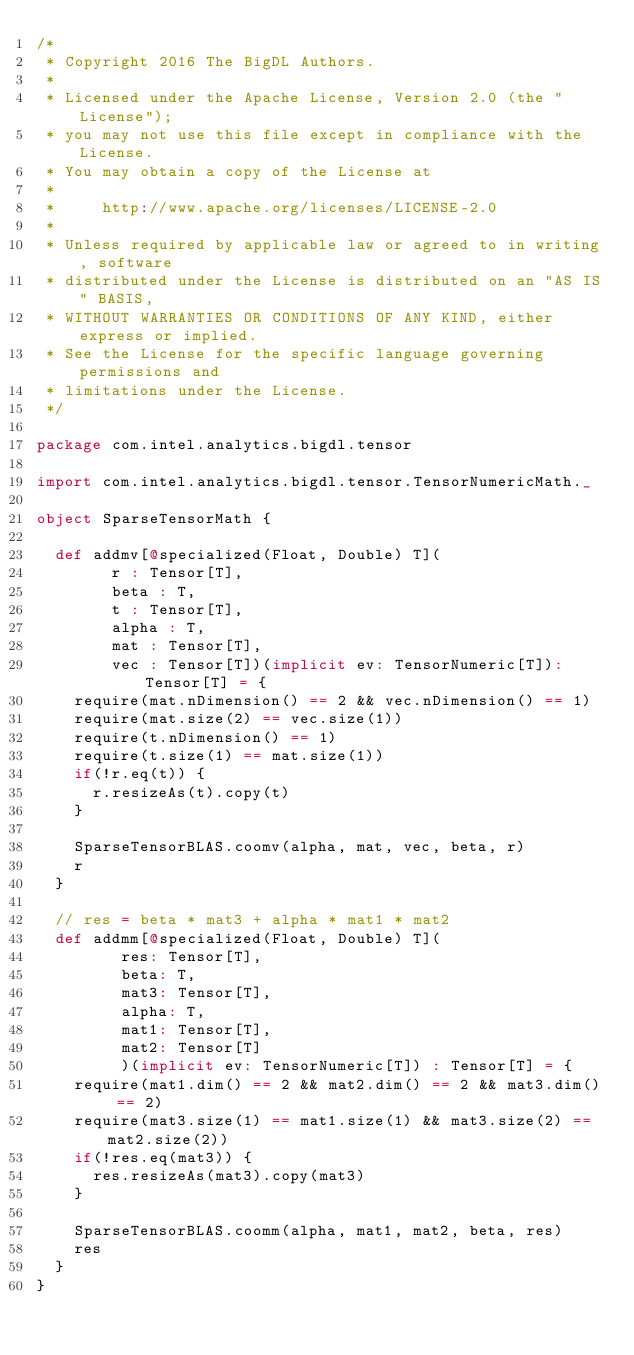<code> <loc_0><loc_0><loc_500><loc_500><_Scala_>/*
 * Copyright 2016 The BigDL Authors.
 *
 * Licensed under the Apache License, Version 2.0 (the "License");
 * you may not use this file except in compliance with the License.
 * You may obtain a copy of the License at
 *
 *     http://www.apache.org/licenses/LICENSE-2.0
 *
 * Unless required by applicable law or agreed to in writing, software
 * distributed under the License is distributed on an "AS IS" BASIS,
 * WITHOUT WARRANTIES OR CONDITIONS OF ANY KIND, either express or implied.
 * See the License for the specific language governing permissions and
 * limitations under the License.
 */

package com.intel.analytics.bigdl.tensor

import com.intel.analytics.bigdl.tensor.TensorNumericMath._

object SparseTensorMath {

  def addmv[@specialized(Float, Double) T](
        r : Tensor[T],
        beta : T,
        t : Tensor[T],
        alpha : T,
        mat : Tensor[T],
        vec : Tensor[T])(implicit ev: TensorNumeric[T]): Tensor[T] = {
    require(mat.nDimension() == 2 && vec.nDimension() == 1)
    require(mat.size(2) == vec.size(1))
    require(t.nDimension() == 1)
    require(t.size(1) == mat.size(1))
    if(!r.eq(t)) {
      r.resizeAs(t).copy(t)
    }

    SparseTensorBLAS.coomv(alpha, mat, vec, beta, r)
    r
  }

  // res = beta * mat3 + alpha * mat1 * mat2
  def addmm[@specialized(Float, Double) T](
         res: Tensor[T],
         beta: T,
         mat3: Tensor[T],
         alpha: T,
         mat1: Tensor[T],
         mat2: Tensor[T]
         )(implicit ev: TensorNumeric[T]) : Tensor[T] = {
    require(mat1.dim() == 2 && mat2.dim() == 2 && mat3.dim() == 2)
    require(mat3.size(1) == mat1.size(1) && mat3.size(2) == mat2.size(2))
    if(!res.eq(mat3)) {
      res.resizeAs(mat3).copy(mat3)
    }

    SparseTensorBLAS.coomm(alpha, mat1, mat2, beta, res)
    res
  }
}
</code> 